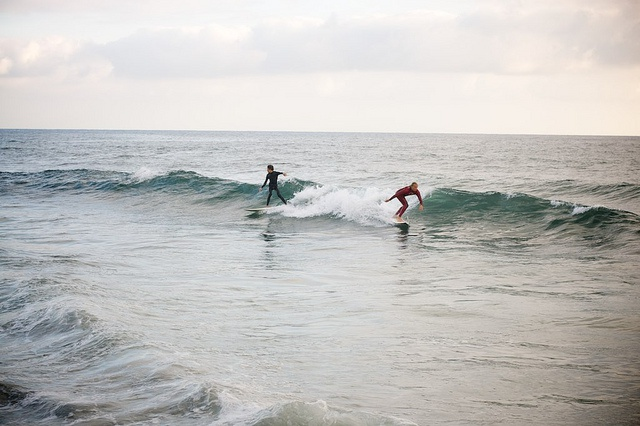Describe the objects in this image and their specific colors. I can see people in lightgray, maroon, black, brown, and gray tones, people in lightgray, black, gray, darkgray, and purple tones, surfboard in lightgray, darkgray, and black tones, and surfboard in lightgray, gray, and darkgray tones in this image. 